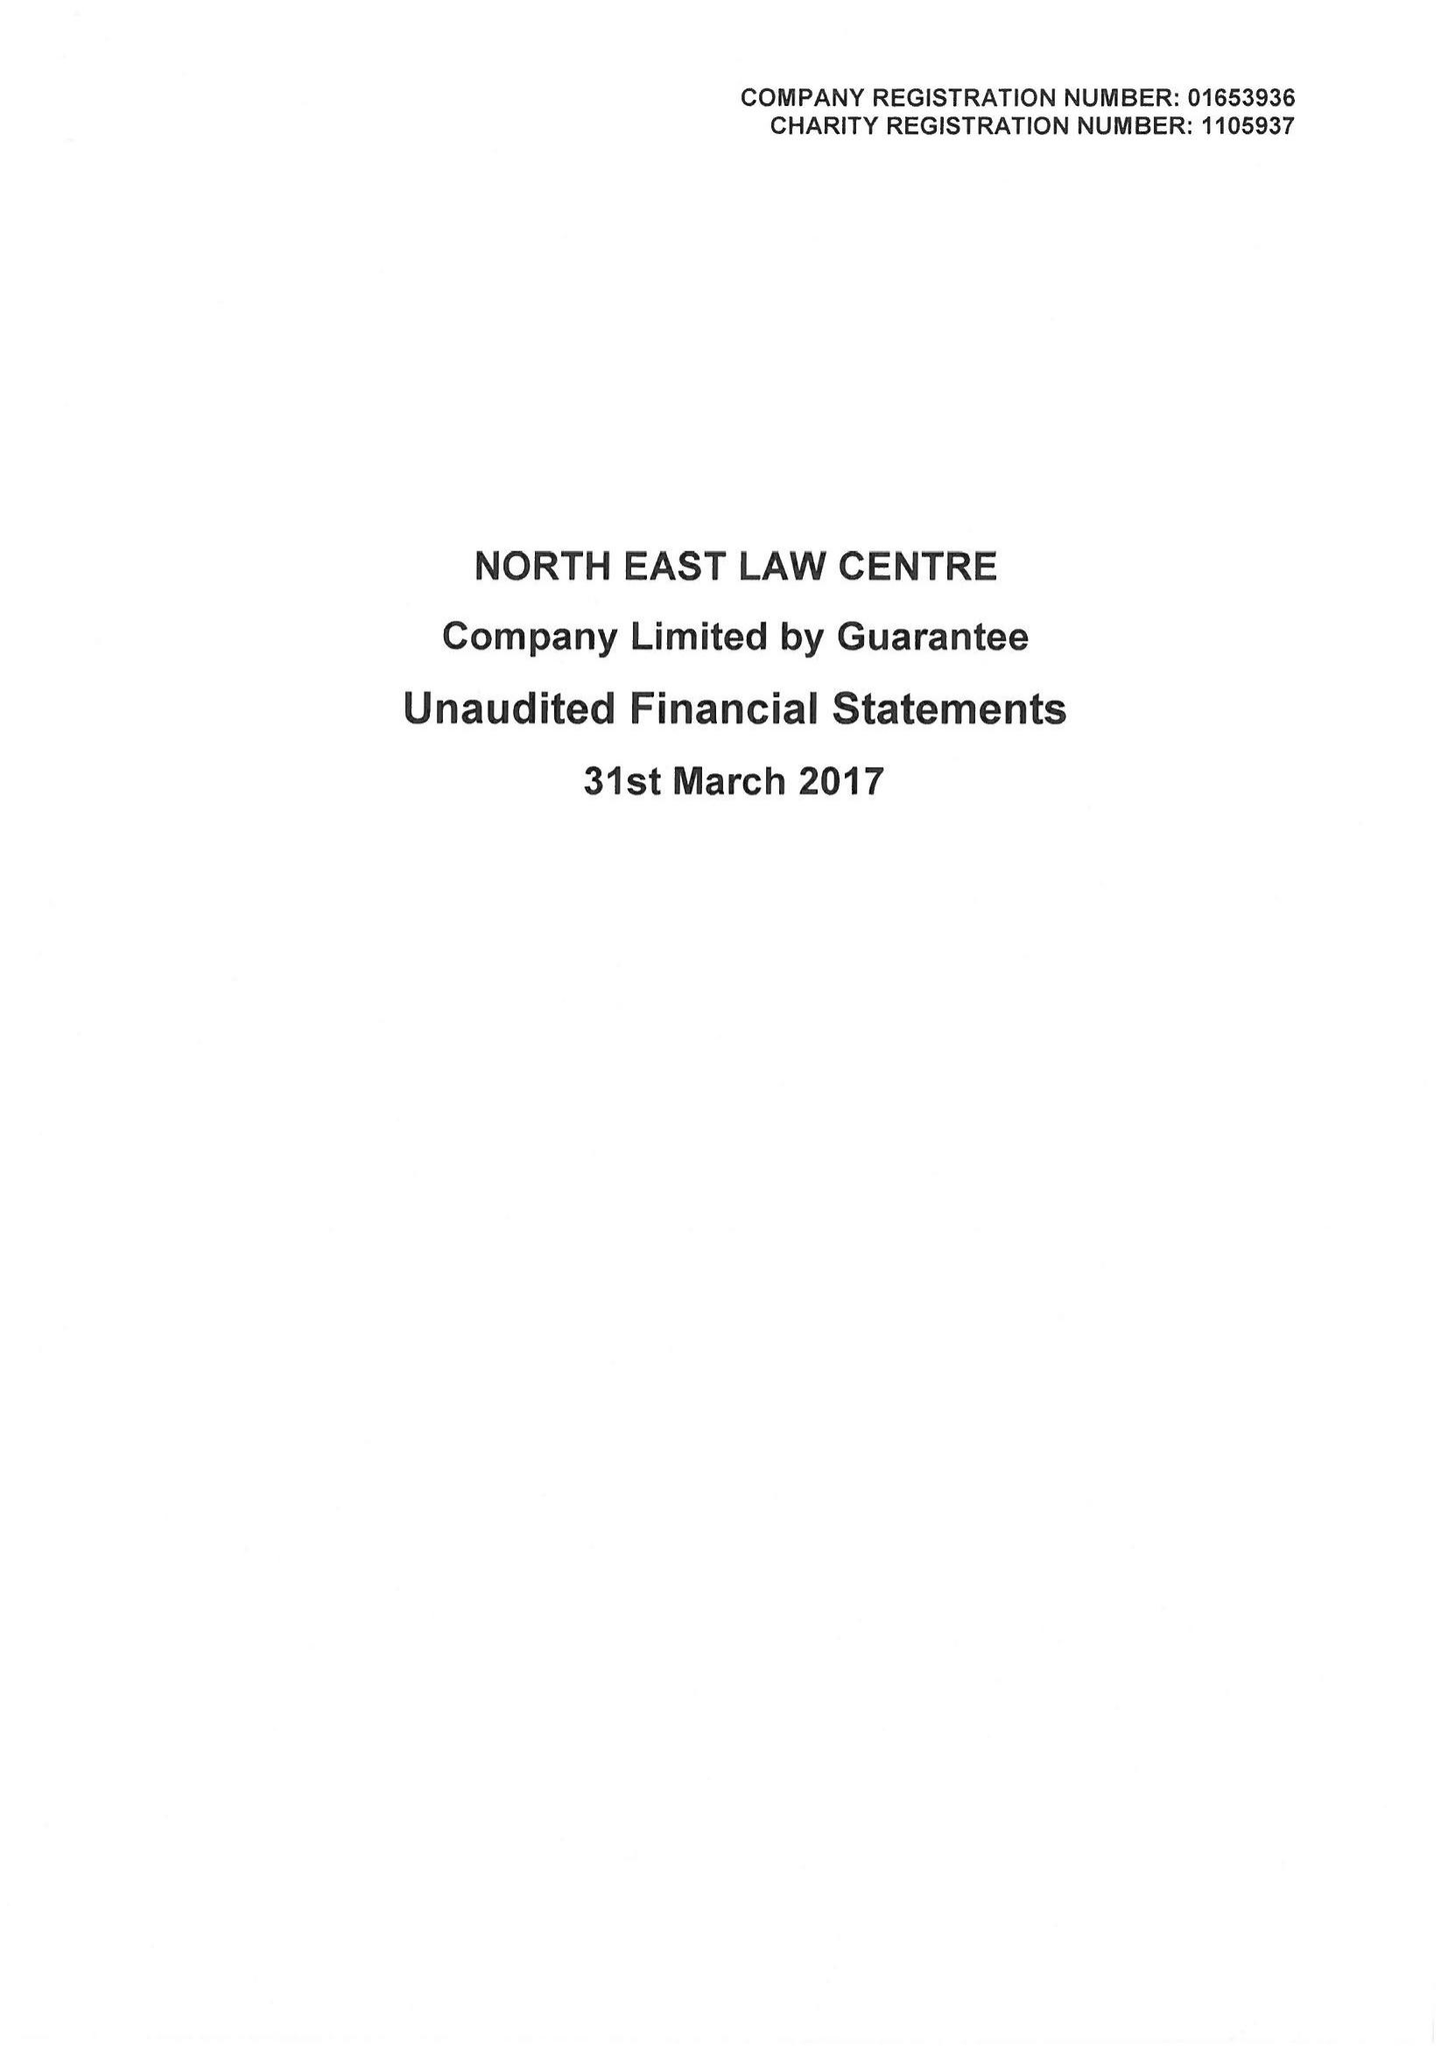What is the value for the spending_annually_in_british_pounds?
Answer the question using a single word or phrase. 265682.00 